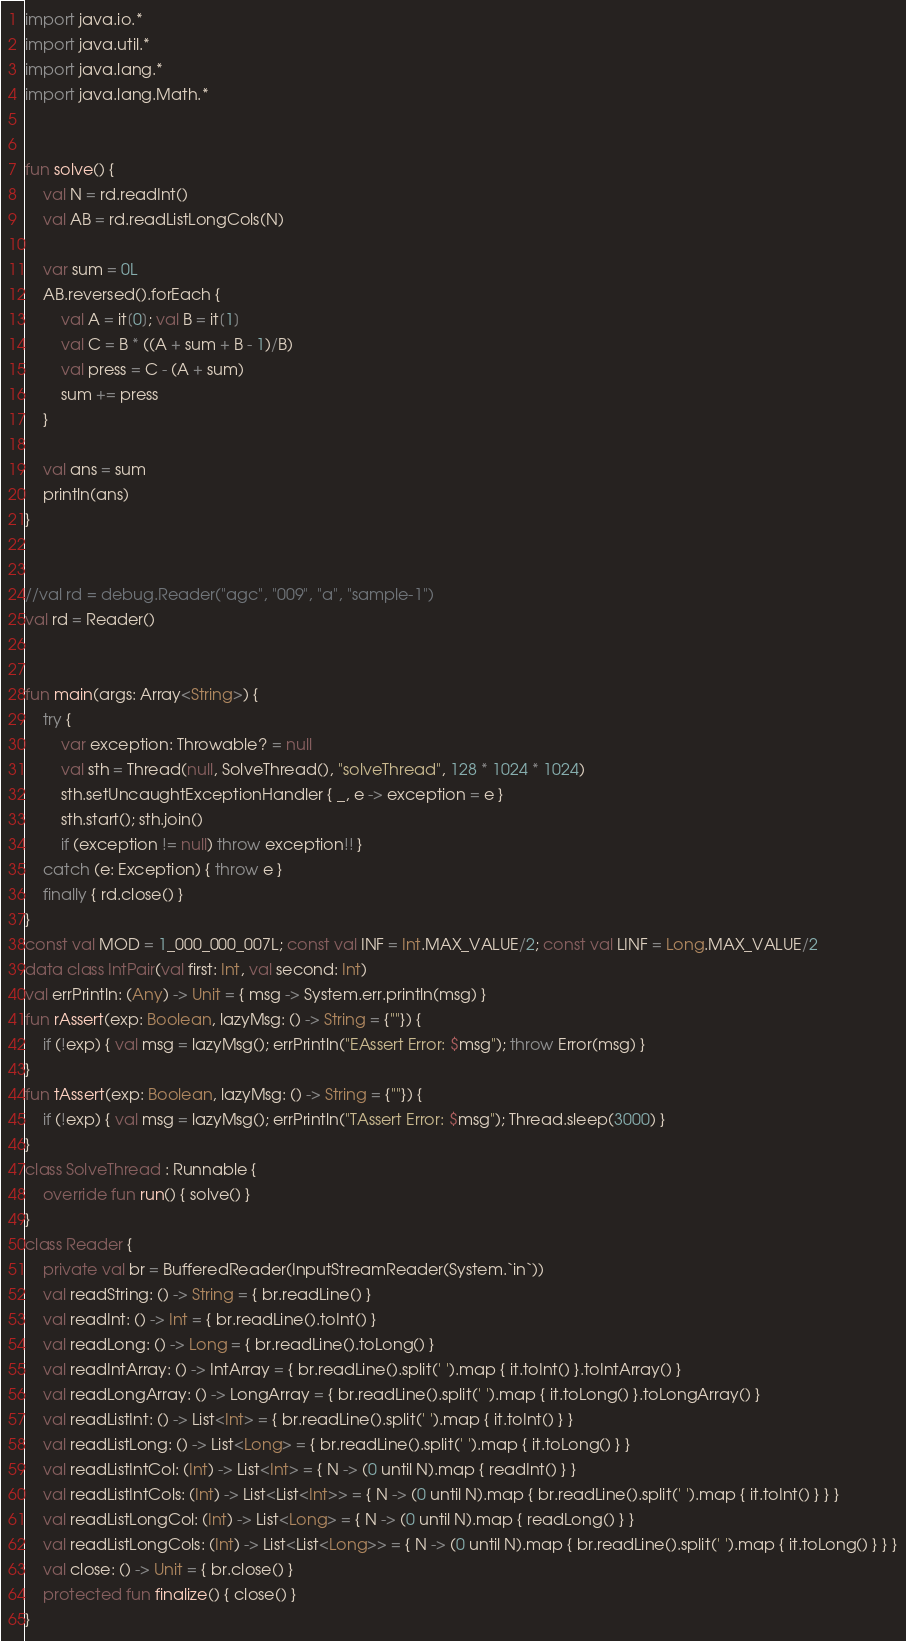<code> <loc_0><loc_0><loc_500><loc_500><_Kotlin_>import java.io.*
import java.util.*
import java.lang.*
import java.lang.Math.*


fun solve() {
    val N = rd.readInt()
    val AB = rd.readListLongCols(N)

    var sum = 0L
    AB.reversed().forEach {
        val A = it[0]; val B = it[1]
        val C = B * ((A + sum + B - 1)/B)
        val press = C - (A + sum)
        sum += press
    }

    val ans = sum
    println(ans)
}


//val rd = debug.Reader("agc", "009", "a", "sample-1")
val rd = Reader()


fun main(args: Array<String>) {
    try {
        var exception: Throwable? = null
        val sth = Thread(null, SolveThread(), "solveThread", 128 * 1024 * 1024)
        sth.setUncaughtExceptionHandler { _, e -> exception = e }
        sth.start(); sth.join()
        if (exception != null) throw exception!! }
    catch (e: Exception) { throw e }
    finally { rd.close() }
}
const val MOD = 1_000_000_007L; const val INF = Int.MAX_VALUE/2; const val LINF = Long.MAX_VALUE/2
data class IntPair(val first: Int, val second: Int)
val errPrintln: (Any) -> Unit = { msg -> System.err.println(msg) }
fun rAssert(exp: Boolean, lazyMsg: () -> String = {""}) {
    if (!exp) { val msg = lazyMsg(); errPrintln("EAssert Error: $msg"); throw Error(msg) }
}
fun tAssert(exp: Boolean, lazyMsg: () -> String = {""}) {
    if (!exp) { val msg = lazyMsg(); errPrintln("TAssert Error: $msg"); Thread.sleep(3000) }
}
class SolveThread : Runnable {
    override fun run() { solve() }
}
class Reader {
    private val br = BufferedReader(InputStreamReader(System.`in`))
    val readString: () -> String = { br.readLine() }
    val readInt: () -> Int = { br.readLine().toInt() }
    val readLong: () -> Long = { br.readLine().toLong() }
    val readIntArray: () -> IntArray = { br.readLine().split(' ').map { it.toInt() }.toIntArray() }
    val readLongArray: () -> LongArray = { br.readLine().split(' ').map { it.toLong() }.toLongArray() }
    val readListInt: () -> List<Int> = { br.readLine().split(' ').map { it.toInt() } }
    val readListLong: () -> List<Long> = { br.readLine().split(' ').map { it.toLong() } }
    val readListIntCol: (Int) -> List<Int> = { N -> (0 until N).map { readInt() } }
    val readListIntCols: (Int) -> List<List<Int>> = { N -> (0 until N).map { br.readLine().split(' ').map { it.toInt() } } }
    val readListLongCol: (Int) -> List<Long> = { N -> (0 until N).map { readLong() } }
    val readListLongCols: (Int) -> List<List<Long>> = { N -> (0 until N).map { br.readLine().split(' ').map { it.toLong() } } }
    val close: () -> Unit = { br.close() }
    protected fun finalize() { close() }
}
</code> 